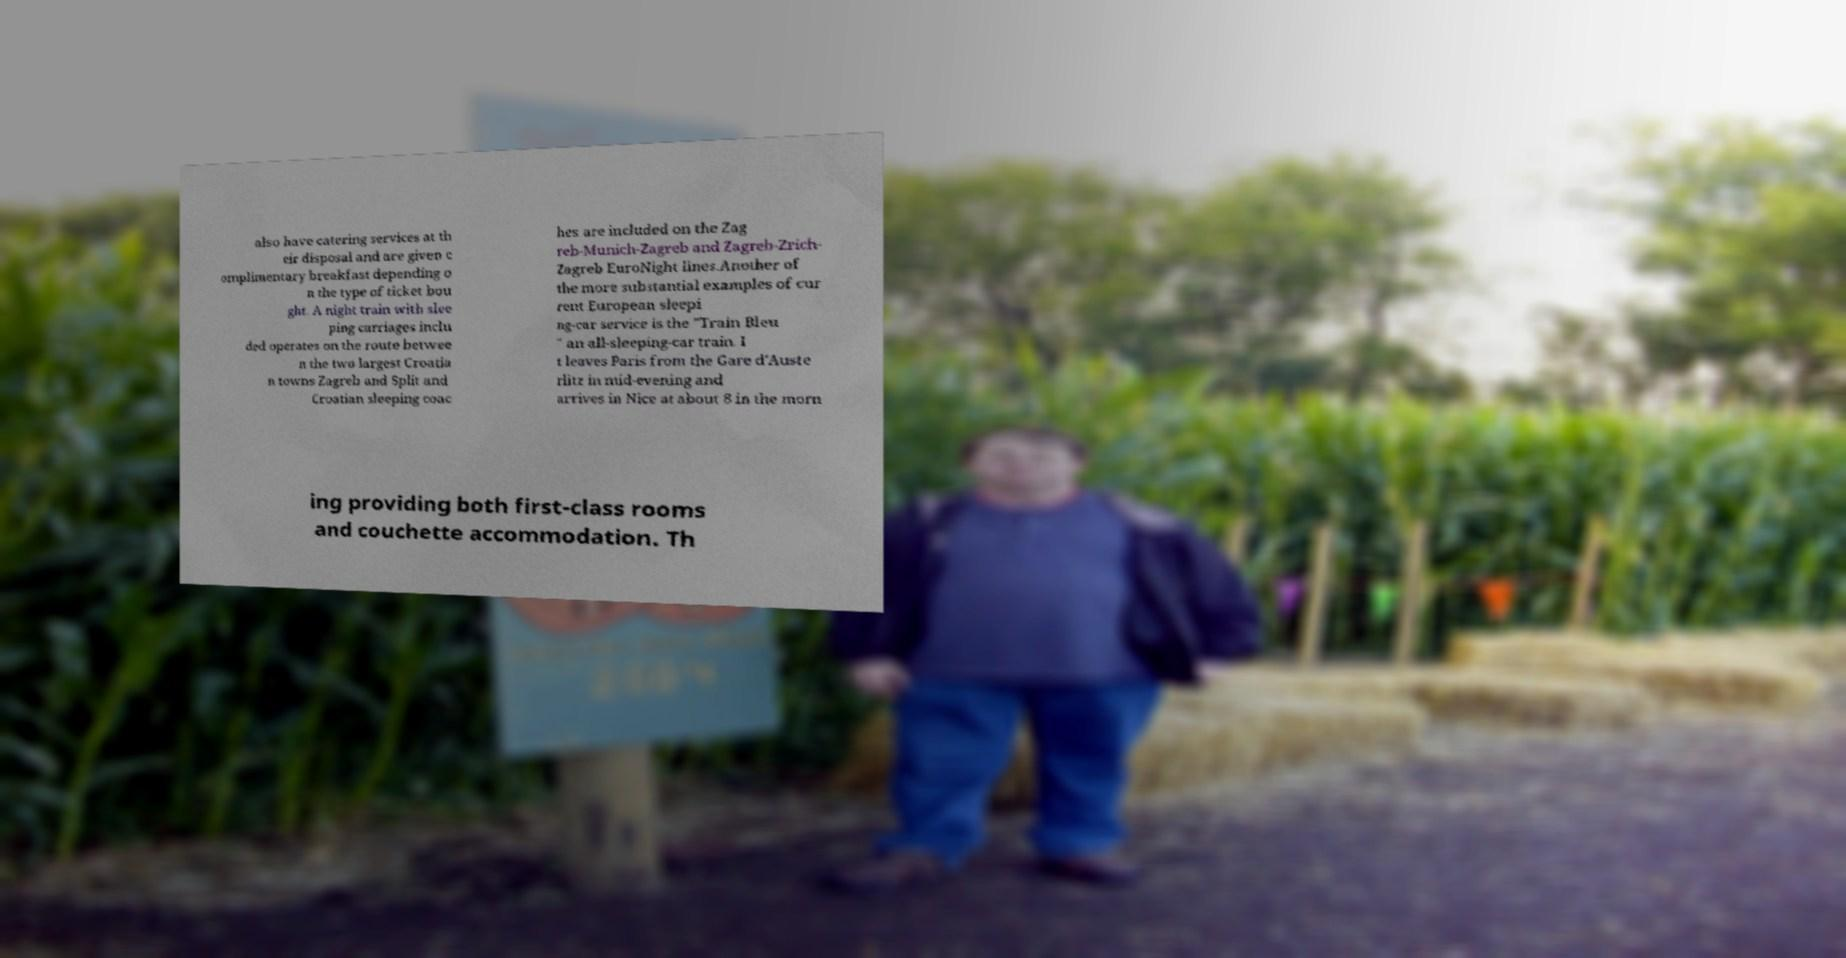Can you read and provide the text displayed in the image?This photo seems to have some interesting text. Can you extract and type it out for me? also have catering services at th eir disposal and are given c omplimentary breakfast depending o n the type of ticket bou ght. A night train with slee ping carriages inclu ded operates on the route betwee n the two largest Croatia n towns Zagreb and Split and Croatian sleeping coac hes are included on the Zag reb-Munich-Zagreb and Zagreb-Zrich- Zagreb EuroNight lines.Another of the more substantial examples of cur rent European sleepi ng-car service is the "Train Bleu " an all-sleeping-car train. I t leaves Paris from the Gare d'Auste rlitz in mid-evening and arrives in Nice at about 8 in the morn ing providing both first-class rooms and couchette accommodation. Th 